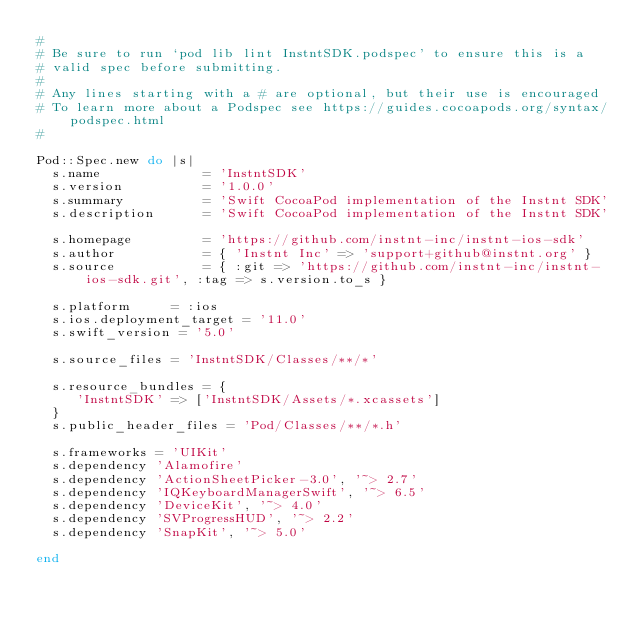<code> <loc_0><loc_0><loc_500><loc_500><_Ruby_>#
# Be sure to run `pod lib lint InstntSDK.podspec' to ensure this is a
# valid spec before submitting.
#
# Any lines starting with a # are optional, but their use is encouraged
# To learn more about a Podspec see https://guides.cocoapods.org/syntax/podspec.html
#

Pod::Spec.new do |s|
  s.name             = 'InstntSDK'
  s.version          = '1.0.0'
  s.summary          = 'Swift CocoaPod implementation of the Instnt SDK'
  s.description      = 'Swift CocoaPod implementation of the Instnt SDK'

  s.homepage         = 'https://github.com/instnt-inc/instnt-ios-sdk'
  s.author           = { 'Instnt Inc' => 'support+github@instnt.org' }
  s.source           = { :git => 'https://github.com/instnt-inc/instnt-ios-sdk.git', :tag => s.version.to_s }
  
  s.platform     = :ios
  s.ios.deployment_target = '11.0'
  s.swift_version = '5.0'

  s.source_files = 'InstntSDK/Classes/**/*'
  
  s.resource_bundles = {
     'InstntSDK' => ['InstntSDK/Assets/*.xcassets']
  }
  s.public_header_files = 'Pod/Classes/**/*.h'
  
  s.frameworks = 'UIKit'
  s.dependency 'Alamofire'
  s.dependency 'ActionSheetPicker-3.0', '~> 2.7'
  s.dependency 'IQKeyboardManagerSwift', '~> 6.5'
  s.dependency 'DeviceKit', '~> 4.0'
  s.dependency 'SVProgressHUD', '~> 2.2'
  s.dependency 'SnapKit', '~> 5.0'

end
</code> 